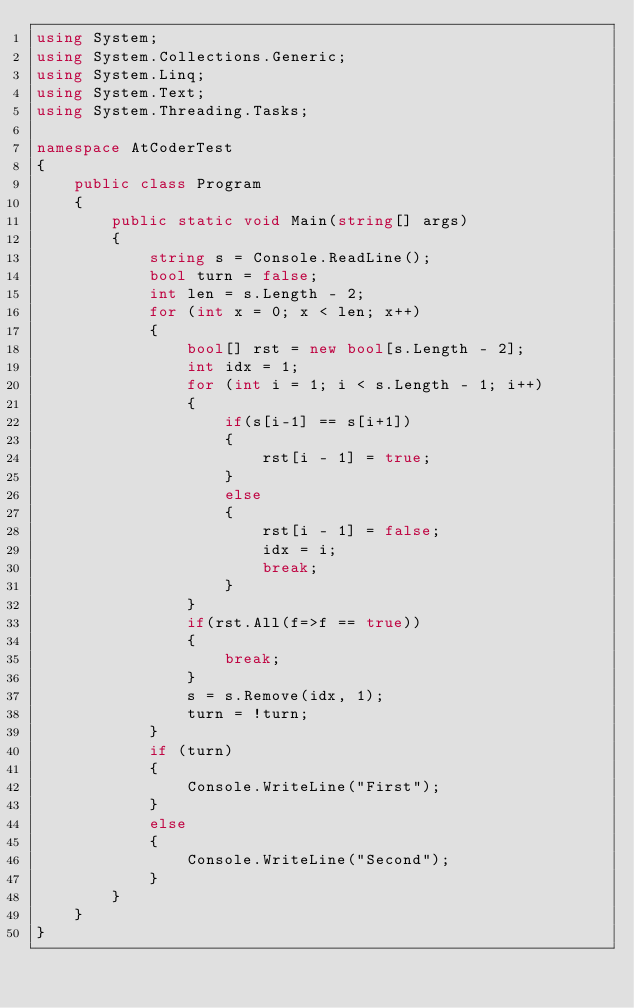Convert code to text. <code><loc_0><loc_0><loc_500><loc_500><_C#_>using System;
using System.Collections.Generic;
using System.Linq;
using System.Text;
using System.Threading.Tasks;

namespace AtCoderTest
{
    public class Program
    {
        public static void Main(string[] args)
        {
            string s = Console.ReadLine();
            bool turn = false;
            int len = s.Length - 2;
            for (int x = 0; x < len; x++)
            {
                bool[] rst = new bool[s.Length - 2];
                int idx = 1;
                for (int i = 1; i < s.Length - 1; i++)
                {
                    if(s[i-1] == s[i+1])
                    {
                        rst[i - 1] = true;
                    }
                    else
                    {
                        rst[i - 1] = false;
                        idx = i;
                        break;
                    }
                }
                if(rst.All(f=>f == true))
                {
                    break;
                }
                s = s.Remove(idx, 1);
                turn = !turn;
            }
            if (turn)
            {
                Console.WriteLine("First");
            }
            else
            {
                Console.WriteLine("Second");
            }
        }
    }
}
</code> 